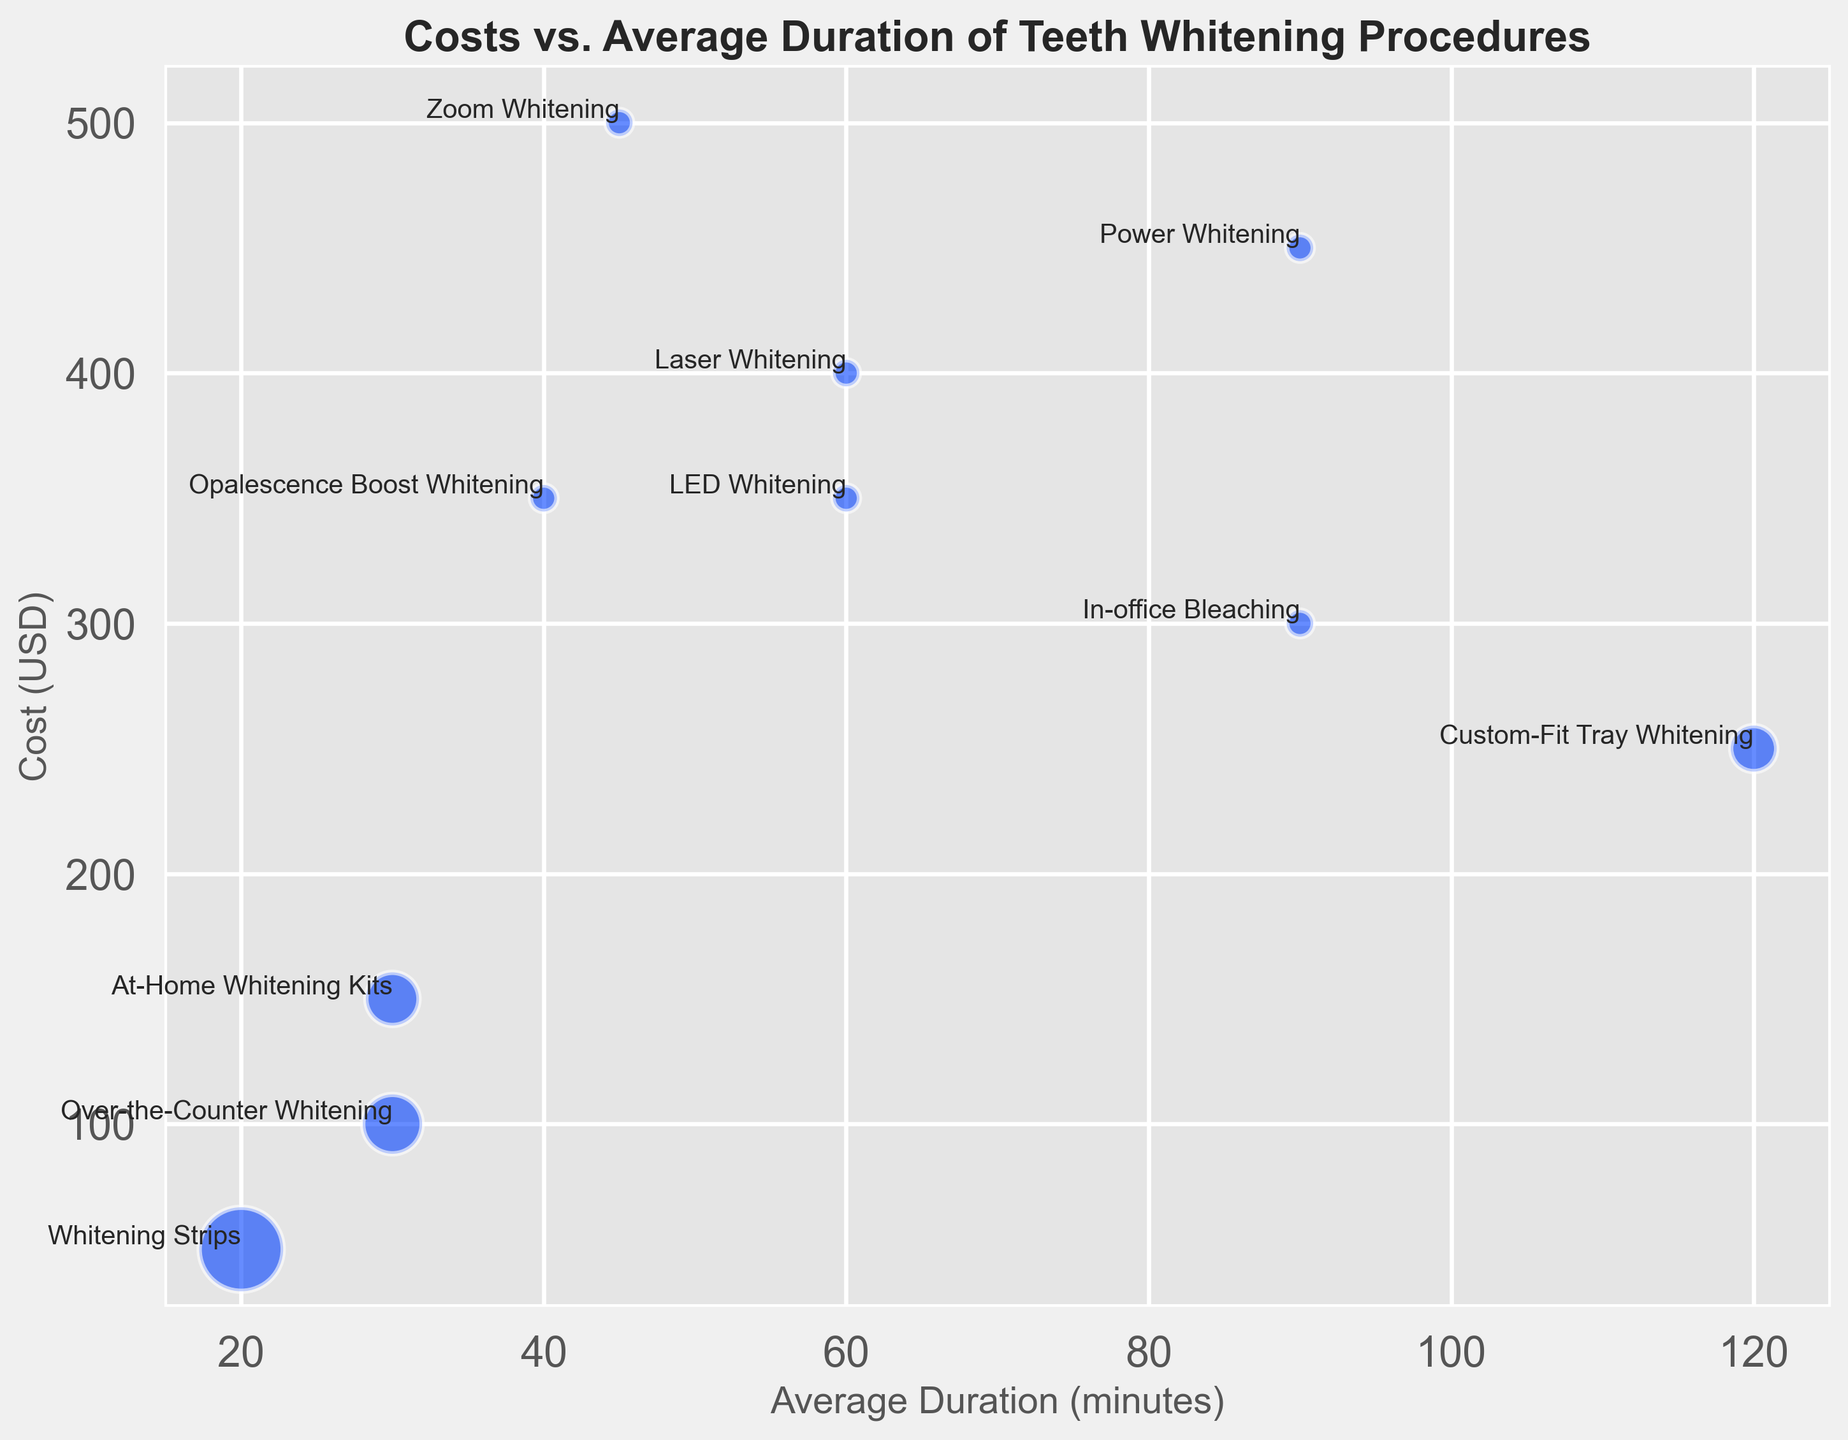What is the cost difference between Laser Whitening and Zoom Whitening? Laser Whitening costs $400 and Zoom Whitening costs $500. The difference is $500 - $400 = $100.
Answer: $100 Which procedure has the shortest average duration? Whitening Strips have the shortest average duration, which is 20 minutes, according to the labeled points in the figure.
Answer: Whitening Strips How many sessions does Over-the-Counter Whitening require and what is its visual representation in terms of bubble size? Over-the-Counter Whitening requires 5 sessions. The visual representation shows larger bubbles since the size is proportional to the number of sessions, indicating 5 sessions scale the bubble size.
Answer: 5 sessions Compare the cost and duration for LED Whitening and Opalescence Boost Whitening? LED Whitening costs $350 and takes 60 minutes, while Opalescence Boost Whitening also costs $350 but takes 40 minutes. Hence, LED Whitening has a longer duration.
Answer: LED Whitening: $350, 60 mins; Opalescence Boost: $350, 40 mins Which procedure has the highest cost and what is its average duration? Zoom Whitening has the highest cost at $500, and its average duration is 45 minutes as shown in the figure.
Answer: Zoom Whitening: $500, 45 mins What's the average cost of In-office Bleaching, Custom-Fit Tray Whitening, and Power Whitening? In-office Bleaching costs $300, Custom-Fit Tray Whitening costs $250, and Power Whitening costs $450. The total cost is $300 + $250 + $450 = $1000, so the average cost = $1000 / 3 = $333.33.
Answer: $333.33 Among the procedures requiring only one session, which one has the second lowest cost? In the figure, we see LED Whitening ($350), Laser Whitening ($400), Zoom Whitening ($500), Power Whitening ($450), Opalescence Boost Whitening ($350), and In-office Bleaching ($300). The second lowest cost among these is LED Whitening ($350).
Answer: LED Whitening What's the total number of sessions required if a patient chooses to undergo At-Home Whitening Kits and Whitening Strips? At-Home Whitening Kits require 4 sessions and Whitening Strips require 10 sessions. Total = 4 + 10 = 14 sessions.
Answer: 14 sessions Considering the cost and duration, which of the procedures would you describe as providing the shortest treatment time for the least cost among the procedures not requiring multiple sessions? Considering cost and duration, Opalescence Boost Whitening provides a moderate cost ($350) and a short duration (40 minutes) among single-session procedures.
Answer: Opalescence Boost Whitening 